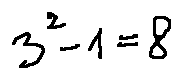Convert formula to latex. <formula><loc_0><loc_0><loc_500><loc_500>3 ^ { 2 } - 1 = 2</formula> 